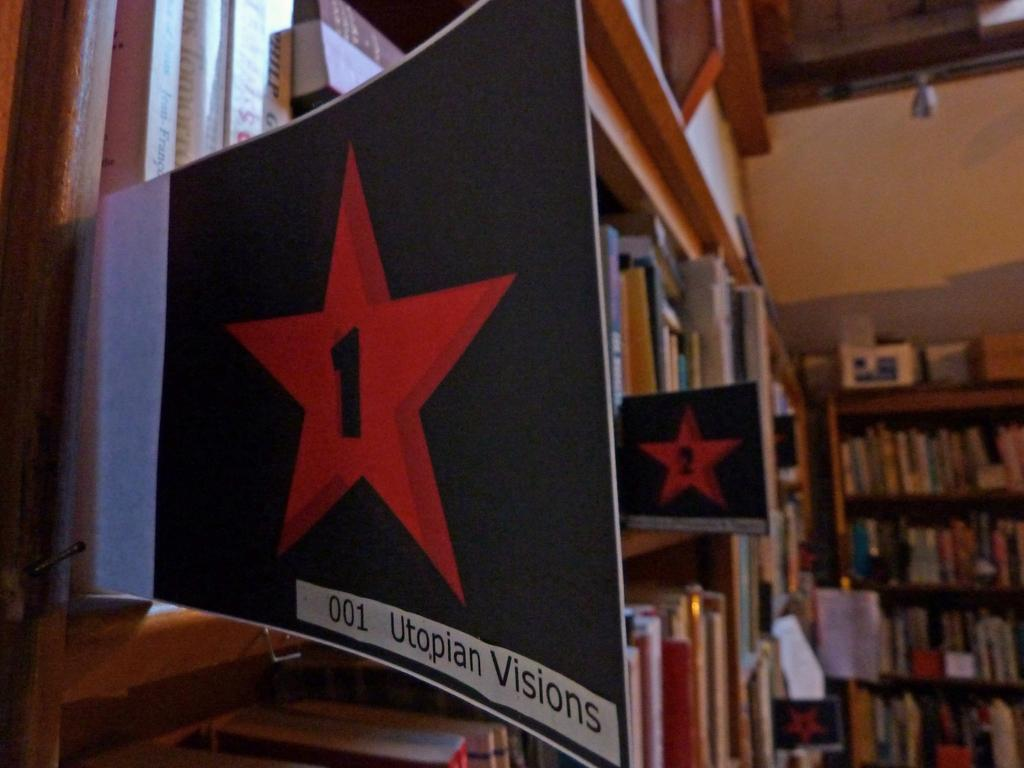<image>
Summarize the visual content of the image. A section of library shelves is labeled with a #1 sign reading Utopian Visions. 